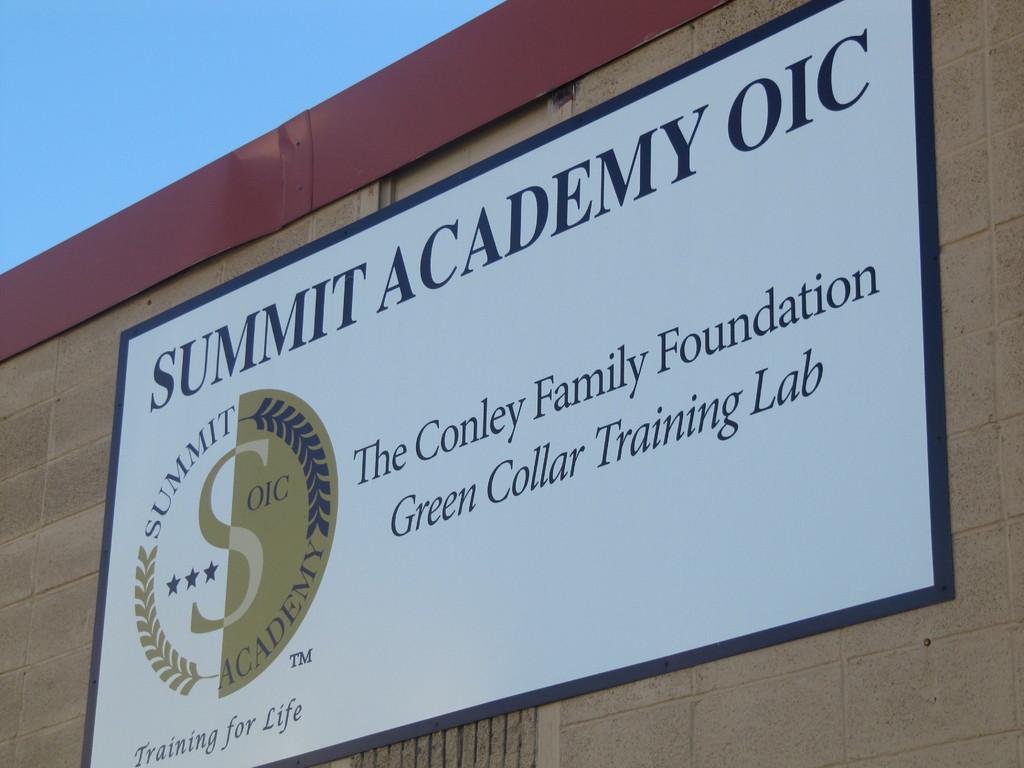What is summit academy oic's motto?
Ensure brevity in your answer.  Training for life. Which lab is on the sign?
Keep it short and to the point. Green collar training lab. 